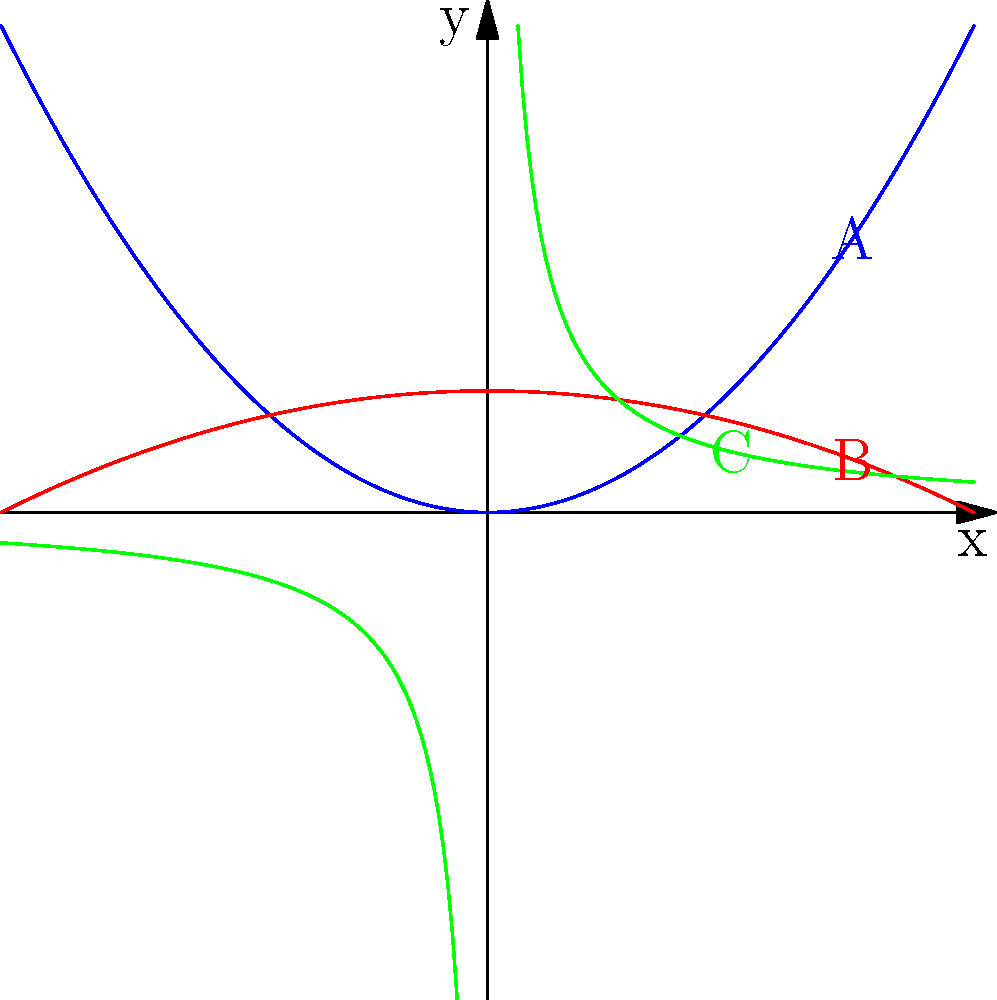Imagine you're planning a birthday party for one of your boys, and you want to create a fun obstacle course in the backyard. You've drawn some curves to represent different paths. Which of these curves (A, B, or C) would be the easiest to make with a jump rope, and what type of curve is it? Let's approach this step-by-step:

1) First, let's look at the shapes of the curves:
   A (blue) opens upward and is symmetric
   B (red) opens downward and is symmetric
   C (green) has two separate parts that approach the axes

2) Now, let's think about what these shapes represent in math terms:
   A looks like a parabola opening upward
   B looks like a parabola opening downward
   C looks like a hyperbola

3) Consider which would be easiest to make with a jump rope:
   - A parabola can be formed by holding one end of the rope still and letting the other end trace a curve as you walk.
   - A hyperbola would be difficult to create with a single rope.

4) Between A and B, curve A (opening upward) would be easier to create because you could stand at the bottom and trace the curve upward with the rope.

5) The general equation of a parabola is:
   $$(x-h)^2 = 4p(y-k)$$
   where $(h,k)$ is the vertex and $p$ is the distance from the vertex to the focus.

Therefore, curve A represents a parabola, which would be the easiest to create with a jump rope for your son's birthday party obstacle course.
Answer: Curve A; Parabola 